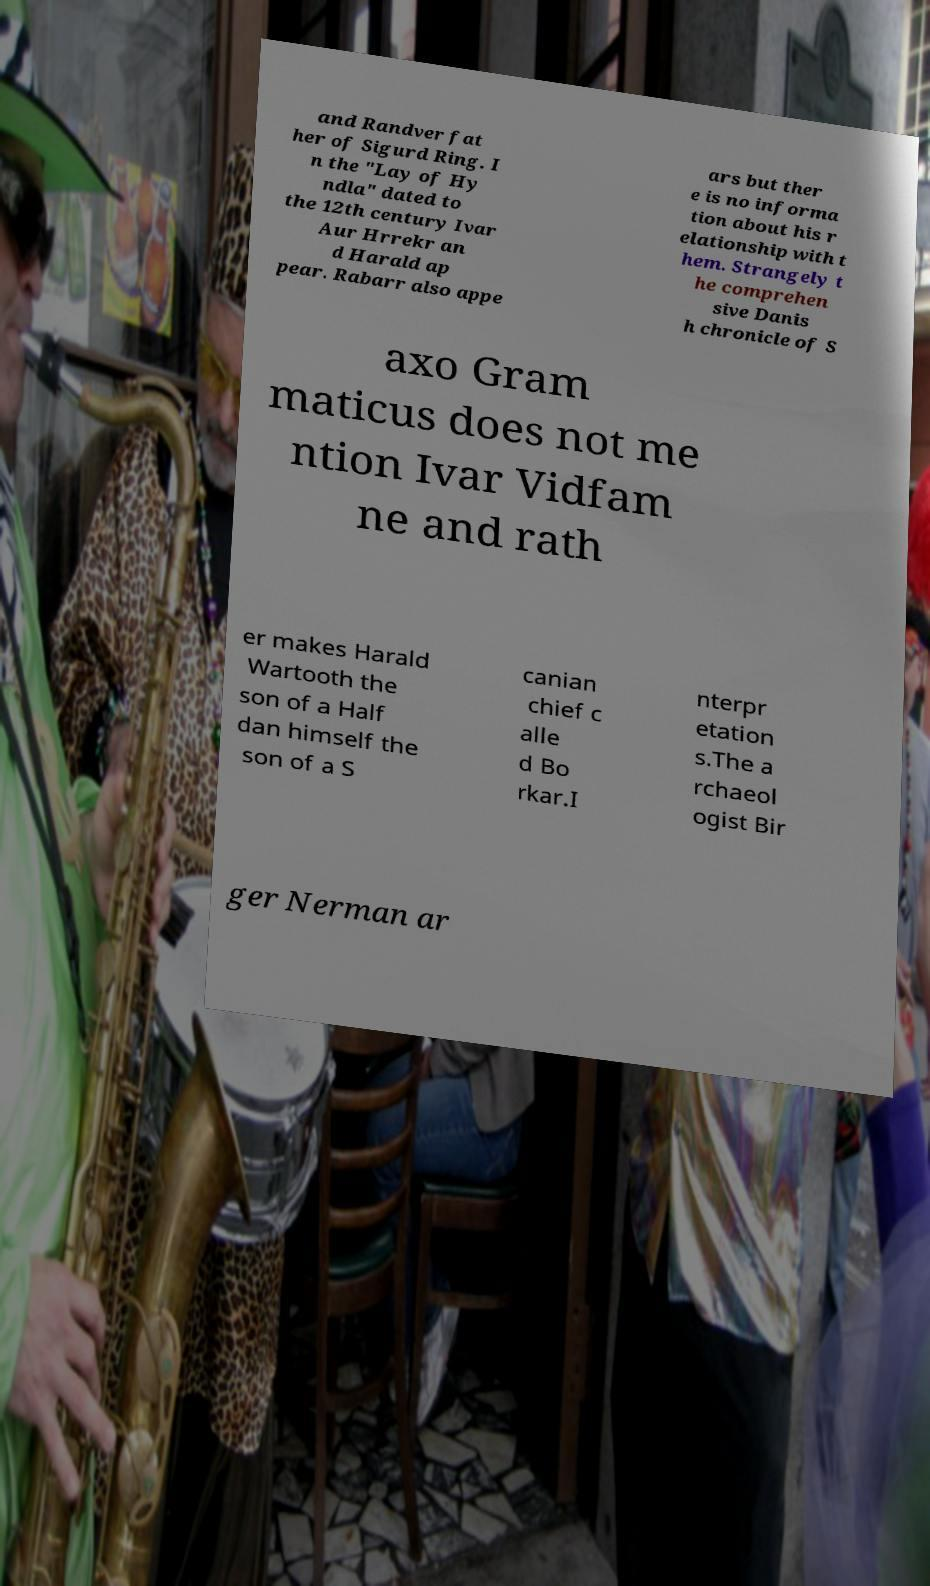What messages or text are displayed in this image? I need them in a readable, typed format. and Randver fat her of Sigurd Ring. I n the "Lay of Hy ndla" dated to the 12th century Ivar Aur Hrrekr an d Harald ap pear. Rabarr also appe ars but ther e is no informa tion about his r elationship with t hem. Strangely t he comprehen sive Danis h chronicle of S axo Gram maticus does not me ntion Ivar Vidfam ne and rath er makes Harald Wartooth the son of a Half dan himself the son of a S canian chief c alle d Bo rkar.I nterpr etation s.The a rchaeol ogist Bir ger Nerman ar 